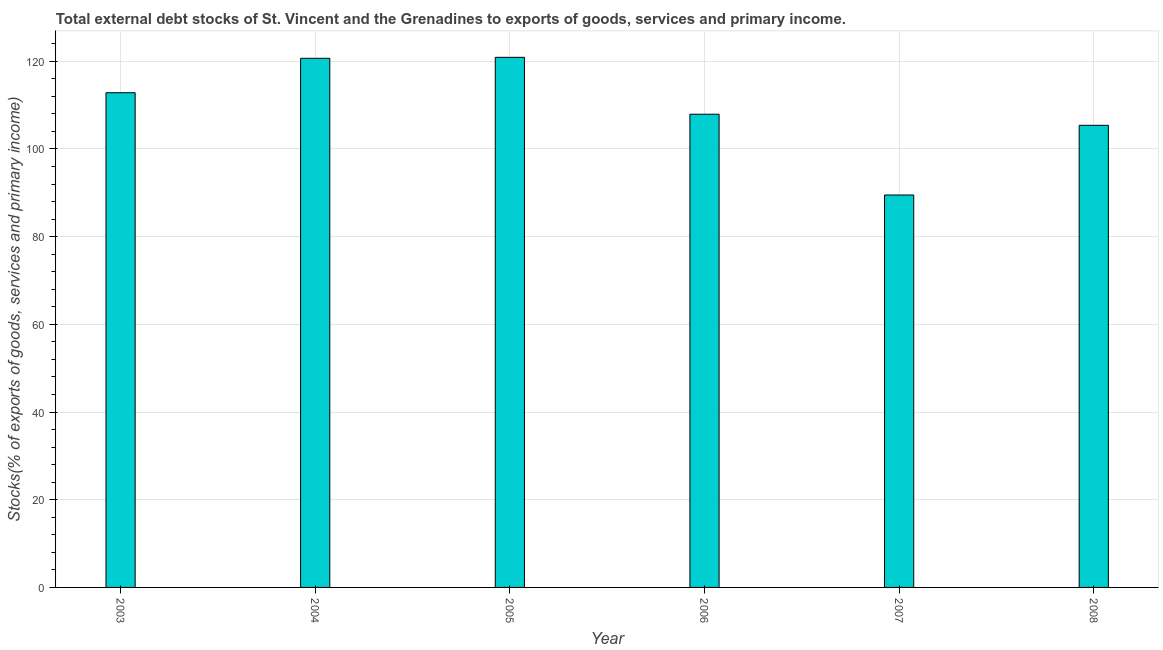Does the graph contain any zero values?
Your response must be concise. No. What is the title of the graph?
Provide a short and direct response. Total external debt stocks of St. Vincent and the Grenadines to exports of goods, services and primary income. What is the label or title of the Y-axis?
Give a very brief answer. Stocks(% of exports of goods, services and primary income). What is the external debt stocks in 2003?
Make the answer very short. 112.83. Across all years, what is the maximum external debt stocks?
Provide a short and direct response. 120.91. Across all years, what is the minimum external debt stocks?
Give a very brief answer. 89.51. In which year was the external debt stocks maximum?
Offer a very short reply. 2005. In which year was the external debt stocks minimum?
Provide a succinct answer. 2007. What is the sum of the external debt stocks?
Ensure brevity in your answer.  657.25. What is the difference between the external debt stocks in 2006 and 2008?
Offer a very short reply. 2.53. What is the average external debt stocks per year?
Give a very brief answer. 109.54. What is the median external debt stocks?
Give a very brief answer. 110.38. Do a majority of the years between 2003 and 2006 (inclusive) have external debt stocks greater than 92 %?
Your answer should be compact. Yes. What is the ratio of the external debt stocks in 2003 to that in 2007?
Make the answer very short. 1.26. Is the difference between the external debt stocks in 2005 and 2007 greater than the difference between any two years?
Keep it short and to the point. Yes. What is the difference between the highest and the second highest external debt stocks?
Provide a short and direct response. 0.22. Is the sum of the external debt stocks in 2003 and 2004 greater than the maximum external debt stocks across all years?
Provide a short and direct response. Yes. What is the difference between the highest and the lowest external debt stocks?
Provide a short and direct response. 31.4. Are all the bars in the graph horizontal?
Provide a short and direct response. No. What is the Stocks(% of exports of goods, services and primary income) of 2003?
Offer a terse response. 112.83. What is the Stocks(% of exports of goods, services and primary income) of 2004?
Provide a short and direct response. 120.68. What is the Stocks(% of exports of goods, services and primary income) in 2005?
Your answer should be compact. 120.91. What is the Stocks(% of exports of goods, services and primary income) in 2006?
Make the answer very short. 107.93. What is the Stocks(% of exports of goods, services and primary income) of 2007?
Provide a succinct answer. 89.51. What is the Stocks(% of exports of goods, services and primary income) of 2008?
Your answer should be compact. 105.4. What is the difference between the Stocks(% of exports of goods, services and primary income) in 2003 and 2004?
Your answer should be very brief. -7.85. What is the difference between the Stocks(% of exports of goods, services and primary income) in 2003 and 2005?
Your response must be concise. -8.07. What is the difference between the Stocks(% of exports of goods, services and primary income) in 2003 and 2006?
Offer a very short reply. 4.9. What is the difference between the Stocks(% of exports of goods, services and primary income) in 2003 and 2007?
Provide a short and direct response. 23.33. What is the difference between the Stocks(% of exports of goods, services and primary income) in 2003 and 2008?
Provide a short and direct response. 7.43. What is the difference between the Stocks(% of exports of goods, services and primary income) in 2004 and 2005?
Ensure brevity in your answer.  -0.22. What is the difference between the Stocks(% of exports of goods, services and primary income) in 2004 and 2006?
Offer a terse response. 12.75. What is the difference between the Stocks(% of exports of goods, services and primary income) in 2004 and 2007?
Offer a very short reply. 31.18. What is the difference between the Stocks(% of exports of goods, services and primary income) in 2004 and 2008?
Your answer should be compact. 15.28. What is the difference between the Stocks(% of exports of goods, services and primary income) in 2005 and 2006?
Your response must be concise. 12.98. What is the difference between the Stocks(% of exports of goods, services and primary income) in 2005 and 2007?
Your answer should be compact. 31.4. What is the difference between the Stocks(% of exports of goods, services and primary income) in 2005 and 2008?
Your response must be concise. 15.51. What is the difference between the Stocks(% of exports of goods, services and primary income) in 2006 and 2007?
Offer a very short reply. 18.42. What is the difference between the Stocks(% of exports of goods, services and primary income) in 2006 and 2008?
Offer a very short reply. 2.53. What is the difference between the Stocks(% of exports of goods, services and primary income) in 2007 and 2008?
Your response must be concise. -15.89. What is the ratio of the Stocks(% of exports of goods, services and primary income) in 2003 to that in 2004?
Give a very brief answer. 0.94. What is the ratio of the Stocks(% of exports of goods, services and primary income) in 2003 to that in 2005?
Your response must be concise. 0.93. What is the ratio of the Stocks(% of exports of goods, services and primary income) in 2003 to that in 2006?
Ensure brevity in your answer.  1.04. What is the ratio of the Stocks(% of exports of goods, services and primary income) in 2003 to that in 2007?
Provide a succinct answer. 1.26. What is the ratio of the Stocks(% of exports of goods, services and primary income) in 2003 to that in 2008?
Give a very brief answer. 1.07. What is the ratio of the Stocks(% of exports of goods, services and primary income) in 2004 to that in 2005?
Keep it short and to the point. 1. What is the ratio of the Stocks(% of exports of goods, services and primary income) in 2004 to that in 2006?
Keep it short and to the point. 1.12. What is the ratio of the Stocks(% of exports of goods, services and primary income) in 2004 to that in 2007?
Ensure brevity in your answer.  1.35. What is the ratio of the Stocks(% of exports of goods, services and primary income) in 2004 to that in 2008?
Your response must be concise. 1.15. What is the ratio of the Stocks(% of exports of goods, services and primary income) in 2005 to that in 2006?
Ensure brevity in your answer.  1.12. What is the ratio of the Stocks(% of exports of goods, services and primary income) in 2005 to that in 2007?
Provide a short and direct response. 1.35. What is the ratio of the Stocks(% of exports of goods, services and primary income) in 2005 to that in 2008?
Your answer should be compact. 1.15. What is the ratio of the Stocks(% of exports of goods, services and primary income) in 2006 to that in 2007?
Provide a short and direct response. 1.21. What is the ratio of the Stocks(% of exports of goods, services and primary income) in 2006 to that in 2008?
Your answer should be very brief. 1.02. What is the ratio of the Stocks(% of exports of goods, services and primary income) in 2007 to that in 2008?
Ensure brevity in your answer.  0.85. 